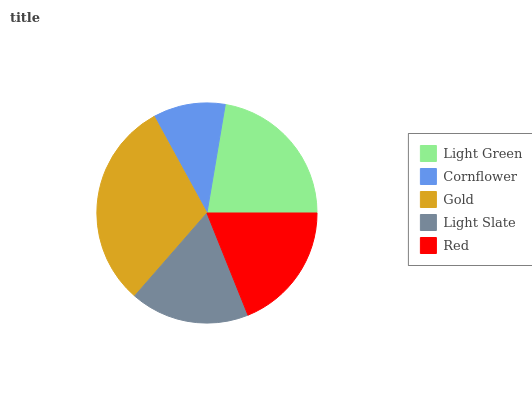Is Cornflower the minimum?
Answer yes or no. Yes. Is Gold the maximum?
Answer yes or no. Yes. Is Gold the minimum?
Answer yes or no. No. Is Cornflower the maximum?
Answer yes or no. No. Is Gold greater than Cornflower?
Answer yes or no. Yes. Is Cornflower less than Gold?
Answer yes or no. Yes. Is Cornflower greater than Gold?
Answer yes or no. No. Is Gold less than Cornflower?
Answer yes or no. No. Is Red the high median?
Answer yes or no. Yes. Is Red the low median?
Answer yes or no. Yes. Is Light Green the high median?
Answer yes or no. No. Is Light Green the low median?
Answer yes or no. No. 